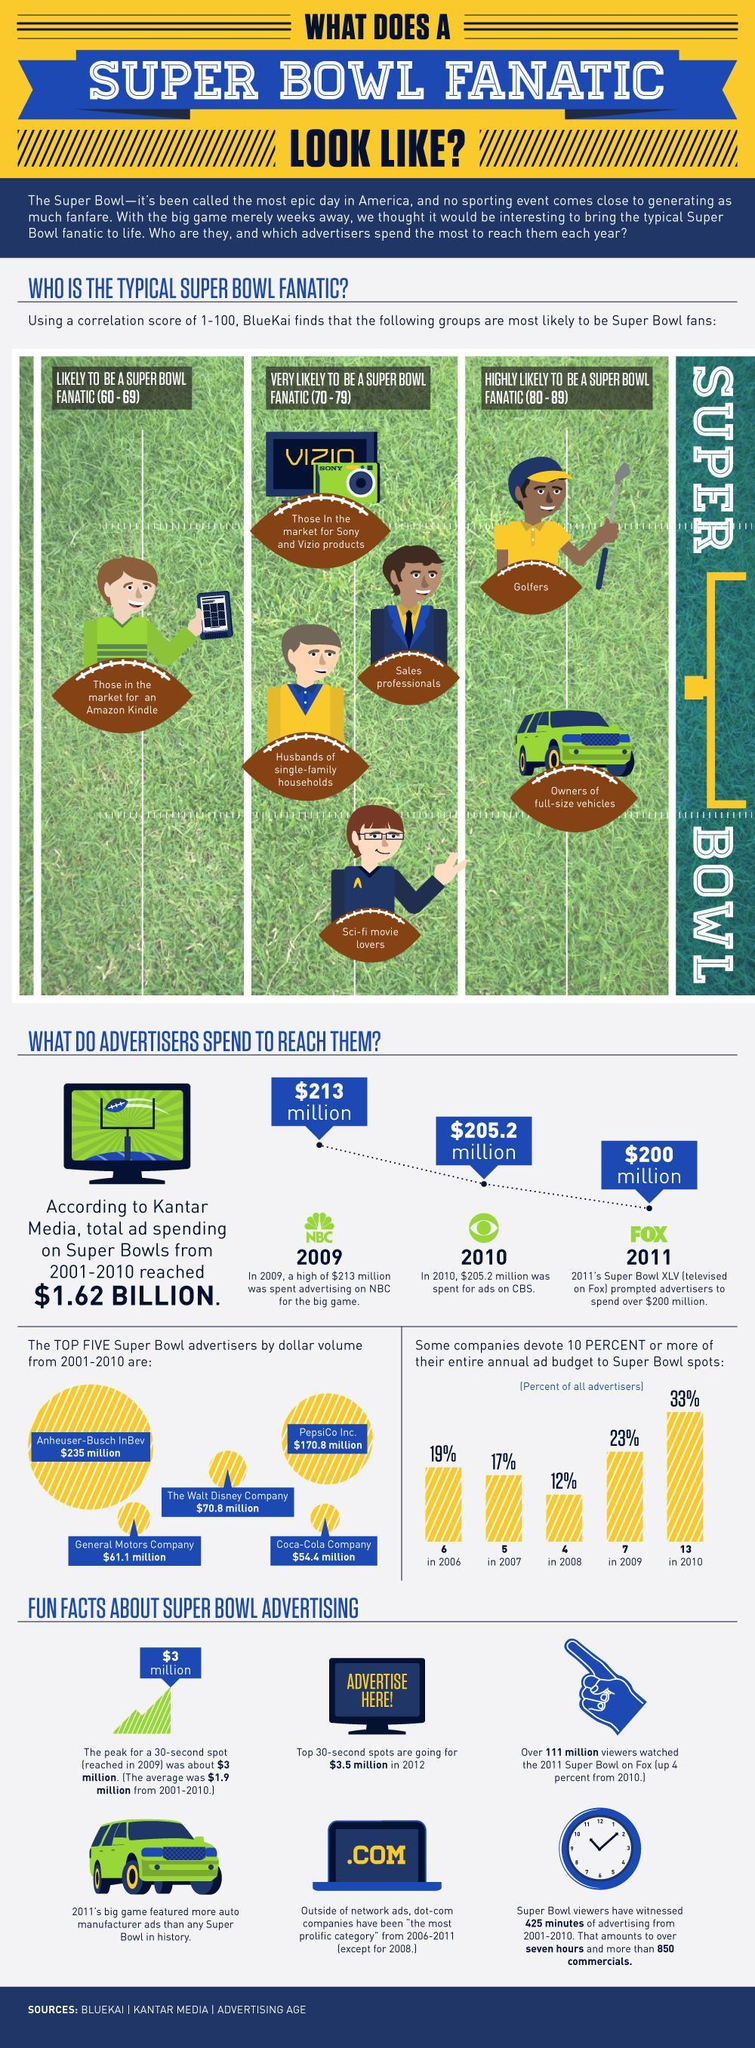How likely is a golfer to be a super bowl fanatic?
Answer the question with a short phrase. Highly likely As per the infographic, in which year more vehicle manufacturer ads were featured than any Super bowl in history? 2011 